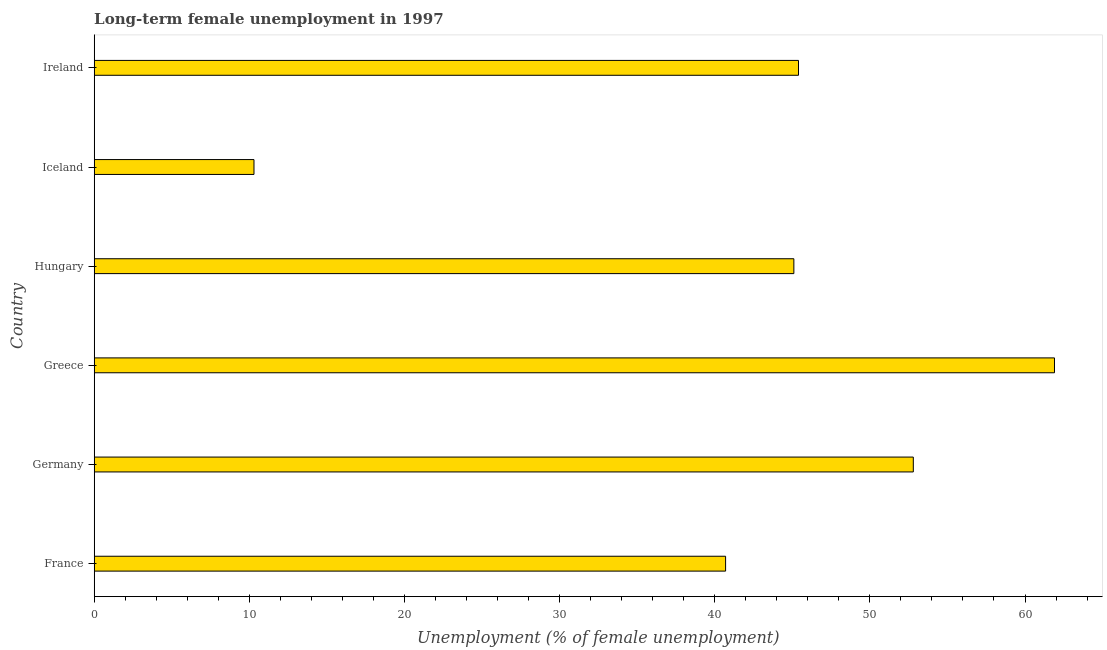What is the title of the graph?
Your answer should be very brief. Long-term female unemployment in 1997. What is the label or title of the X-axis?
Provide a succinct answer. Unemployment (% of female unemployment). What is the label or title of the Y-axis?
Your answer should be compact. Country. What is the long-term female unemployment in Iceland?
Provide a short and direct response. 10.3. Across all countries, what is the maximum long-term female unemployment?
Offer a very short reply. 61.9. Across all countries, what is the minimum long-term female unemployment?
Ensure brevity in your answer.  10.3. In which country was the long-term female unemployment maximum?
Provide a succinct answer. Greece. In which country was the long-term female unemployment minimum?
Make the answer very short. Iceland. What is the sum of the long-term female unemployment?
Make the answer very short. 256.2. What is the difference between the long-term female unemployment in France and Greece?
Ensure brevity in your answer.  -21.2. What is the average long-term female unemployment per country?
Give a very brief answer. 42.7. What is the median long-term female unemployment?
Keep it short and to the point. 45.25. In how many countries, is the long-term female unemployment greater than 48 %?
Give a very brief answer. 2. What is the ratio of the long-term female unemployment in Greece to that in Iceland?
Provide a succinct answer. 6.01. Is the long-term female unemployment in Germany less than that in Hungary?
Offer a terse response. No. What is the difference between the highest and the second highest long-term female unemployment?
Give a very brief answer. 9.1. What is the difference between the highest and the lowest long-term female unemployment?
Your answer should be compact. 51.6. Are all the bars in the graph horizontal?
Make the answer very short. Yes. Are the values on the major ticks of X-axis written in scientific E-notation?
Give a very brief answer. No. What is the Unemployment (% of female unemployment) of France?
Keep it short and to the point. 40.7. What is the Unemployment (% of female unemployment) of Germany?
Provide a succinct answer. 52.8. What is the Unemployment (% of female unemployment) in Greece?
Give a very brief answer. 61.9. What is the Unemployment (% of female unemployment) of Hungary?
Your answer should be very brief. 45.1. What is the Unemployment (% of female unemployment) of Iceland?
Provide a short and direct response. 10.3. What is the Unemployment (% of female unemployment) in Ireland?
Your answer should be very brief. 45.4. What is the difference between the Unemployment (% of female unemployment) in France and Germany?
Your response must be concise. -12.1. What is the difference between the Unemployment (% of female unemployment) in France and Greece?
Your answer should be very brief. -21.2. What is the difference between the Unemployment (% of female unemployment) in France and Hungary?
Your answer should be very brief. -4.4. What is the difference between the Unemployment (% of female unemployment) in France and Iceland?
Make the answer very short. 30.4. What is the difference between the Unemployment (% of female unemployment) in France and Ireland?
Offer a very short reply. -4.7. What is the difference between the Unemployment (% of female unemployment) in Germany and Greece?
Give a very brief answer. -9.1. What is the difference between the Unemployment (% of female unemployment) in Germany and Hungary?
Provide a succinct answer. 7.7. What is the difference between the Unemployment (% of female unemployment) in Germany and Iceland?
Make the answer very short. 42.5. What is the difference between the Unemployment (% of female unemployment) in Germany and Ireland?
Your answer should be compact. 7.4. What is the difference between the Unemployment (% of female unemployment) in Greece and Iceland?
Your response must be concise. 51.6. What is the difference between the Unemployment (% of female unemployment) in Hungary and Iceland?
Give a very brief answer. 34.8. What is the difference between the Unemployment (% of female unemployment) in Iceland and Ireland?
Ensure brevity in your answer.  -35.1. What is the ratio of the Unemployment (% of female unemployment) in France to that in Germany?
Give a very brief answer. 0.77. What is the ratio of the Unemployment (% of female unemployment) in France to that in Greece?
Your answer should be compact. 0.66. What is the ratio of the Unemployment (% of female unemployment) in France to that in Hungary?
Provide a succinct answer. 0.9. What is the ratio of the Unemployment (% of female unemployment) in France to that in Iceland?
Ensure brevity in your answer.  3.95. What is the ratio of the Unemployment (% of female unemployment) in France to that in Ireland?
Provide a short and direct response. 0.9. What is the ratio of the Unemployment (% of female unemployment) in Germany to that in Greece?
Your response must be concise. 0.85. What is the ratio of the Unemployment (% of female unemployment) in Germany to that in Hungary?
Ensure brevity in your answer.  1.17. What is the ratio of the Unemployment (% of female unemployment) in Germany to that in Iceland?
Your answer should be compact. 5.13. What is the ratio of the Unemployment (% of female unemployment) in Germany to that in Ireland?
Provide a succinct answer. 1.16. What is the ratio of the Unemployment (% of female unemployment) in Greece to that in Hungary?
Provide a succinct answer. 1.37. What is the ratio of the Unemployment (% of female unemployment) in Greece to that in Iceland?
Provide a short and direct response. 6.01. What is the ratio of the Unemployment (% of female unemployment) in Greece to that in Ireland?
Offer a terse response. 1.36. What is the ratio of the Unemployment (% of female unemployment) in Hungary to that in Iceland?
Your answer should be compact. 4.38. What is the ratio of the Unemployment (% of female unemployment) in Iceland to that in Ireland?
Provide a succinct answer. 0.23. 